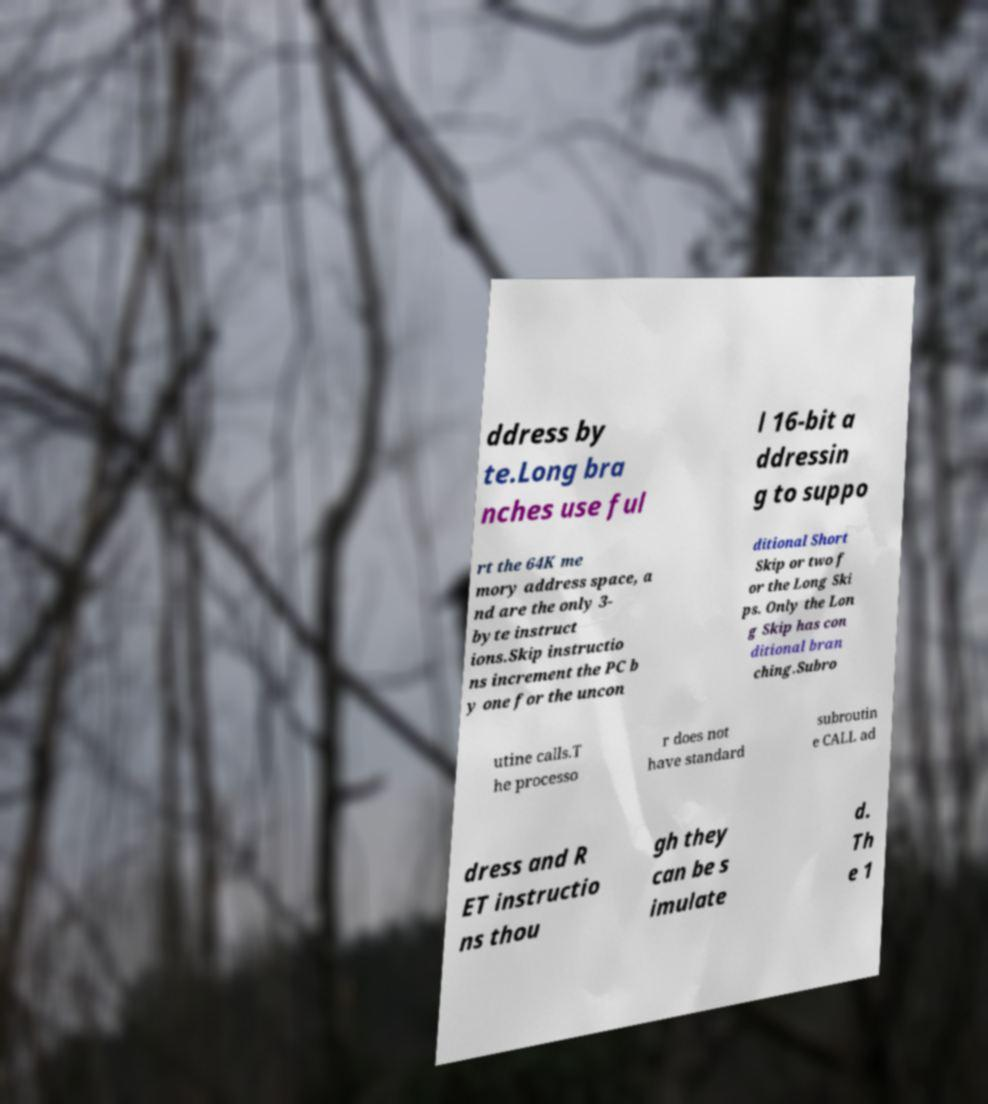For documentation purposes, I need the text within this image transcribed. Could you provide that? ddress by te.Long bra nches use ful l 16-bit a ddressin g to suppo rt the 64K me mory address space, a nd are the only 3- byte instruct ions.Skip instructio ns increment the PC b y one for the uncon ditional Short Skip or two f or the Long Ski ps. Only the Lon g Skip has con ditional bran ching.Subro utine calls.T he processo r does not have standard subroutin e CALL ad dress and R ET instructio ns thou gh they can be s imulate d. Th e 1 